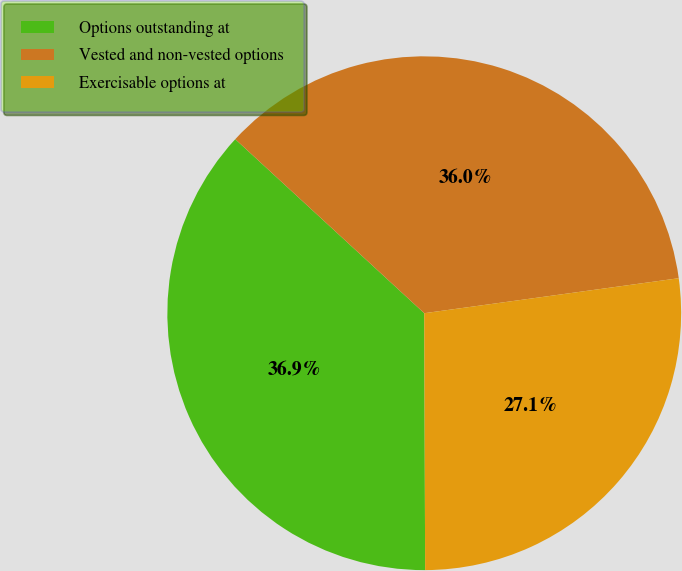<chart> <loc_0><loc_0><loc_500><loc_500><pie_chart><fcel>Options outstanding at<fcel>Vested and non-vested options<fcel>Exercisable options at<nl><fcel>36.9%<fcel>35.98%<fcel>27.12%<nl></chart> 